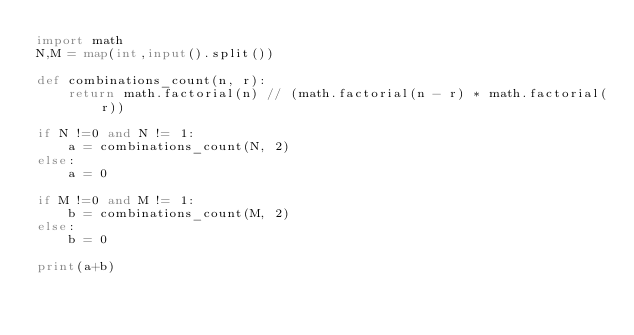<code> <loc_0><loc_0><loc_500><loc_500><_Python_>import math
N,M = map(int,input().split())

def combinations_count(n, r):
    return math.factorial(n) // (math.factorial(n - r) * math.factorial(r))

if N !=0 and N != 1:
    a = combinations_count(N, 2)
else:
    a = 0

if M !=0 and M != 1:
    b = combinations_count(M, 2)
else:
    b = 0

print(a+b)</code> 